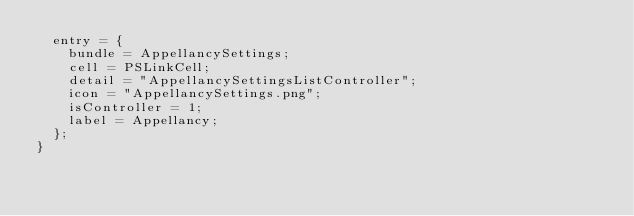Convert code to text. <code><loc_0><loc_0><loc_500><loc_500><_XML_>	entry = {
		bundle = AppellancySettings;
		cell = PSLinkCell;
		detail = "AppellancySettingsListController";
		icon = "AppellancySettings.png";
		isController = 1;
		label = Appellancy;
	};
}</code> 